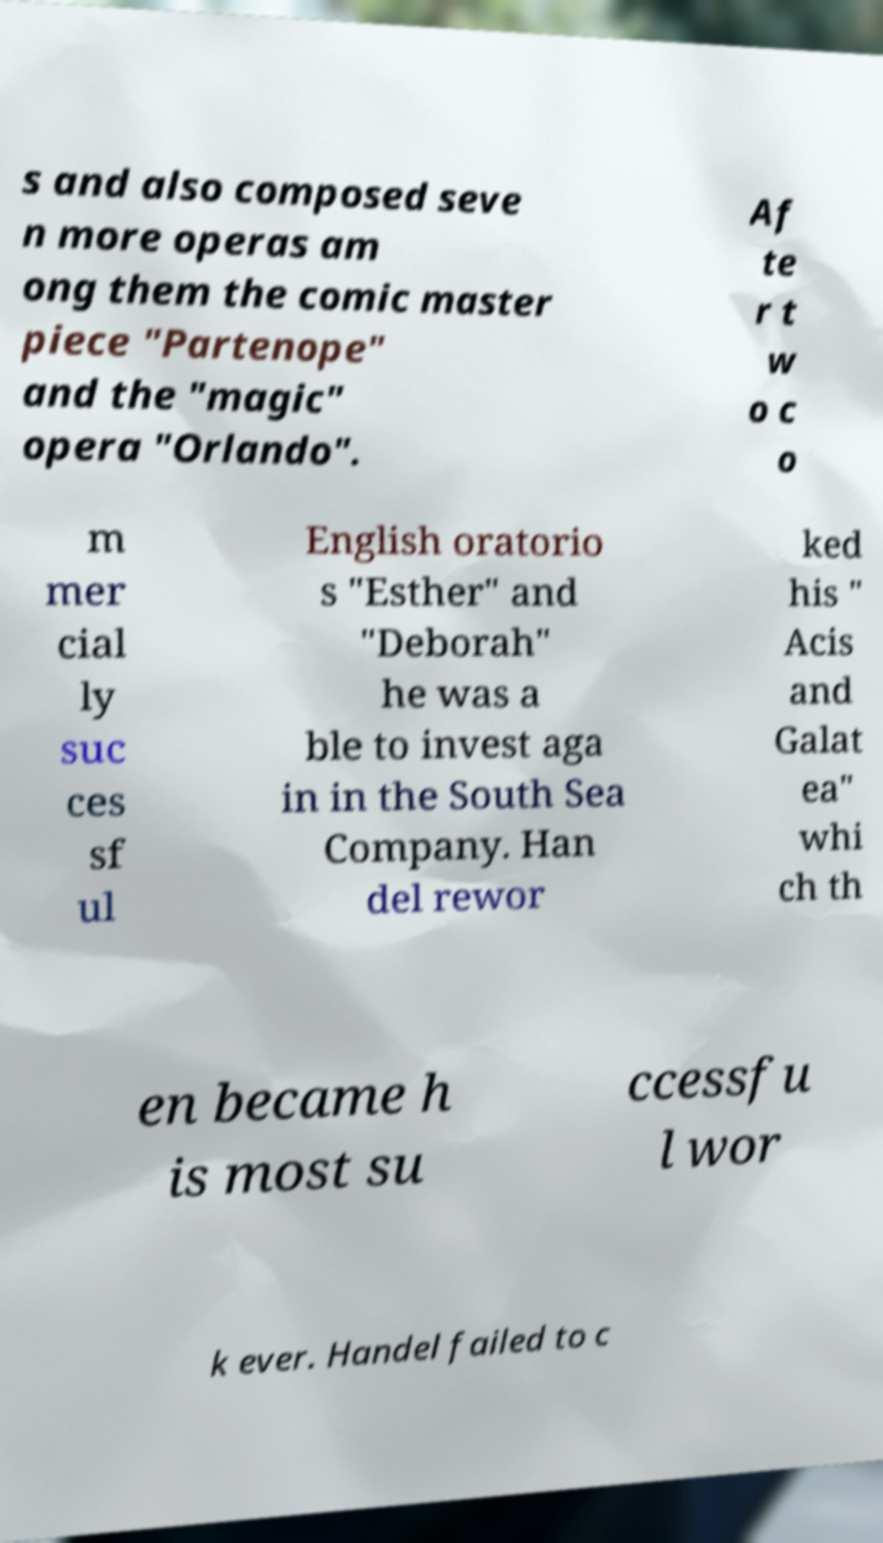Can you accurately transcribe the text from the provided image for me? s and also composed seve n more operas am ong them the comic master piece "Partenope" and the "magic" opera "Orlando". Af te r t w o c o m mer cial ly suc ces sf ul English oratorio s "Esther" and "Deborah" he was a ble to invest aga in in the South Sea Company. Han del rewor ked his " Acis and Galat ea" whi ch th en became h is most su ccessfu l wor k ever. Handel failed to c 